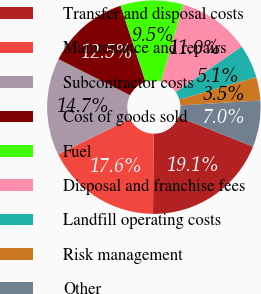Convert chart. <chart><loc_0><loc_0><loc_500><loc_500><pie_chart><fcel>Transfer and disposal costs<fcel>Maintenance and repairs<fcel>Subcontractor costs<fcel>Cost of goods sold<fcel>Fuel<fcel>Disposal and franchise fees<fcel>Landfill operating costs<fcel>Risk management<fcel>Other<nl><fcel>19.1%<fcel>17.59%<fcel>14.7%<fcel>12.53%<fcel>9.47%<fcel>10.99%<fcel>5.05%<fcel>3.54%<fcel>7.02%<nl></chart> 